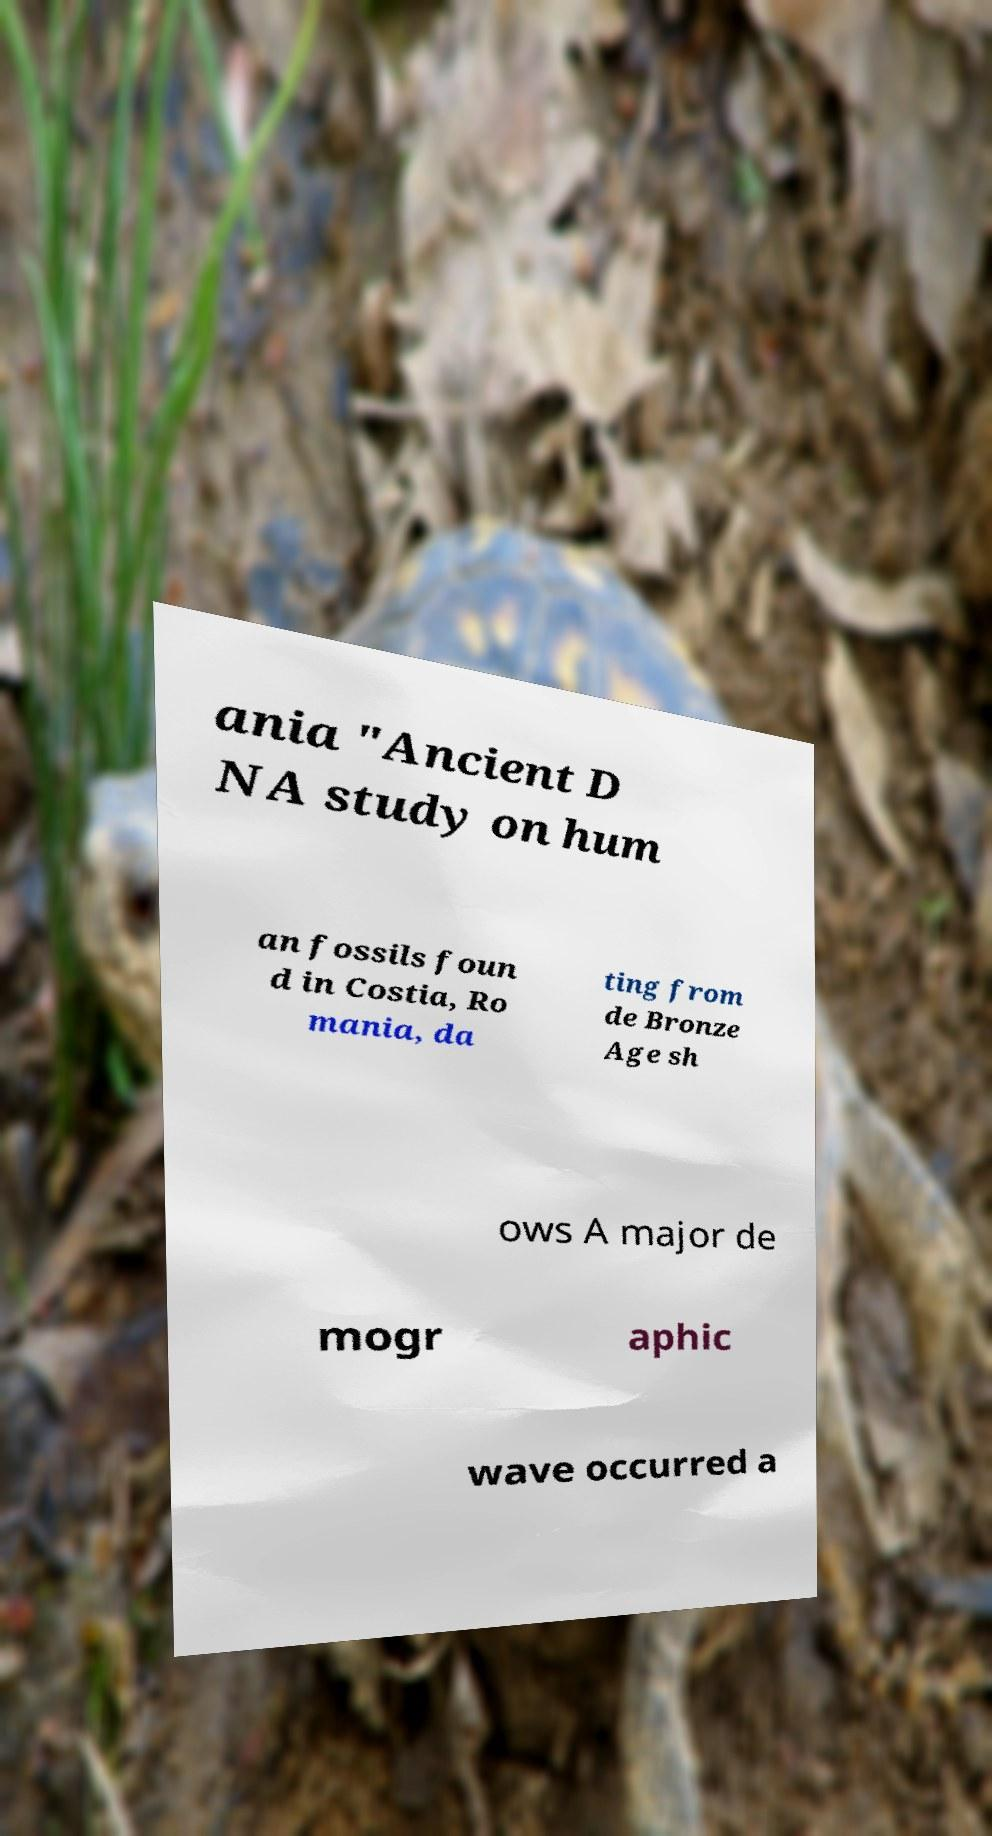Could you assist in decoding the text presented in this image and type it out clearly? ania "Ancient D NA study on hum an fossils foun d in Costia, Ro mania, da ting from de Bronze Age sh ows A major de mogr aphic wave occurred a 